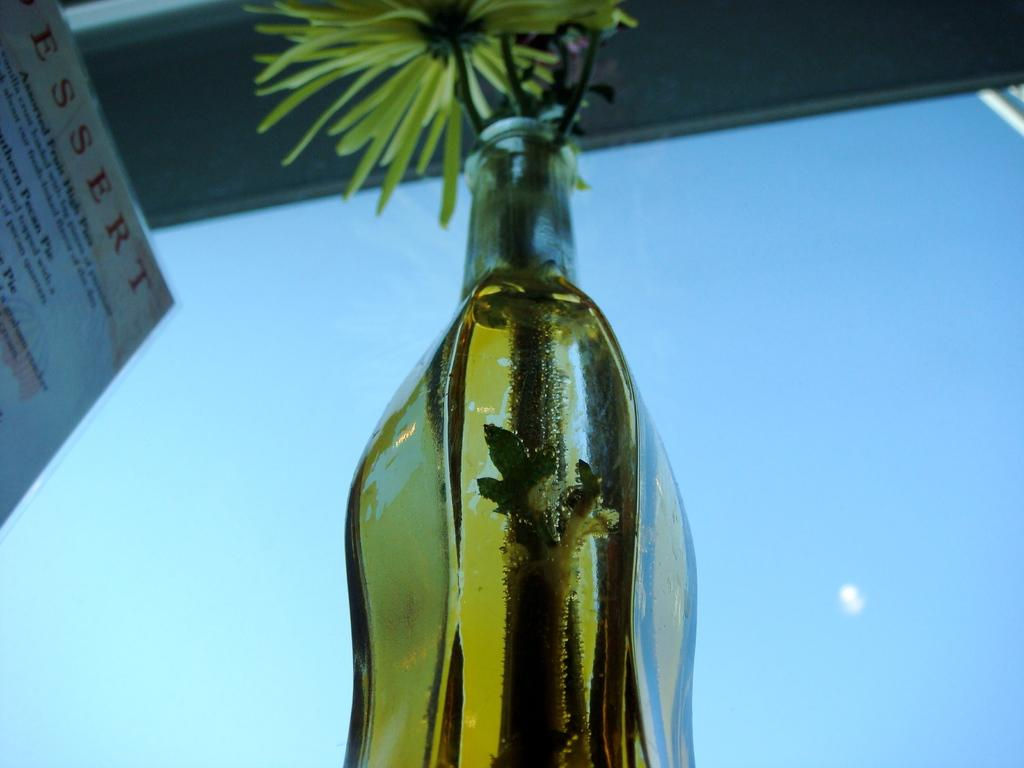What object in the image contains flowers? The bottle in the image contains flowers. What can be seen in the background of the image? The sky is visible in the image. What is present on a wall or surface in the image? There is a poster in the image. What type of fowl can be seen in the image? There are no fowl present in the image. How many frogs are sitting on the bottle in the image? There are no frogs present in the image. 